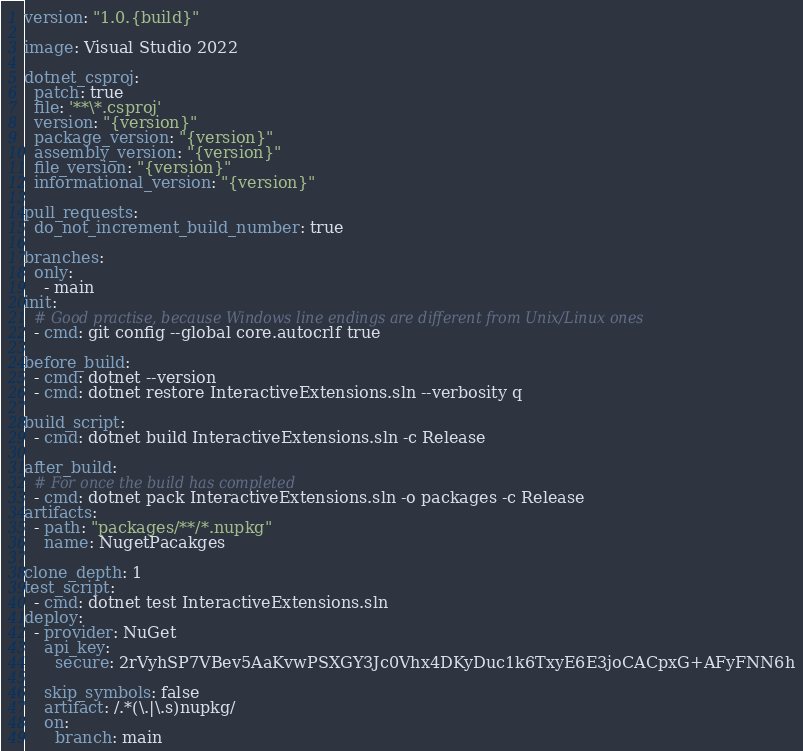Convert code to text. <code><loc_0><loc_0><loc_500><loc_500><_YAML_>version: "1.0.{build}"

image: Visual Studio 2022

dotnet_csproj:
  patch: true
  file: '**\*.csproj'
  version: "{version}"
  package_version: "{version}"
  assembly_version: "{version}"
  file_version: "{version}"
  informational_version: "{version}"

pull_requests:
  do_not_increment_build_number: true

branches:
  only:
    - main
init:
  # Good practise, because Windows line endings are different from Unix/Linux ones
  - cmd: git config --global core.autocrlf true

before_build:
  - cmd: dotnet --version
  - cmd: dotnet restore InteractiveExtensions.sln --verbosity q
 
build_script:
  - cmd: dotnet build InteractiveExtensions.sln -c Release

after_build:
  # For once the build has completed
  - cmd: dotnet pack InteractiveExtensions.sln -o packages -c Release
artifacts:
  - path: "packages/**/*.nupkg"
    name: NugetPacakges

clone_depth: 1
test_script:
  - cmd: dotnet test InteractiveExtensions.sln
deploy:
  - provider: NuGet
    api_key:
      secure: 2rVyhSP7VBev5AaKvwPSXGY3Jc0Vhx4DKyDuc1k6TxyE6E3joCACpxG+AFyFNN6h

    skip_symbols: false
    artifact: /.*(\.|\.s)nupkg/
    on:
      branch: main
</code> 